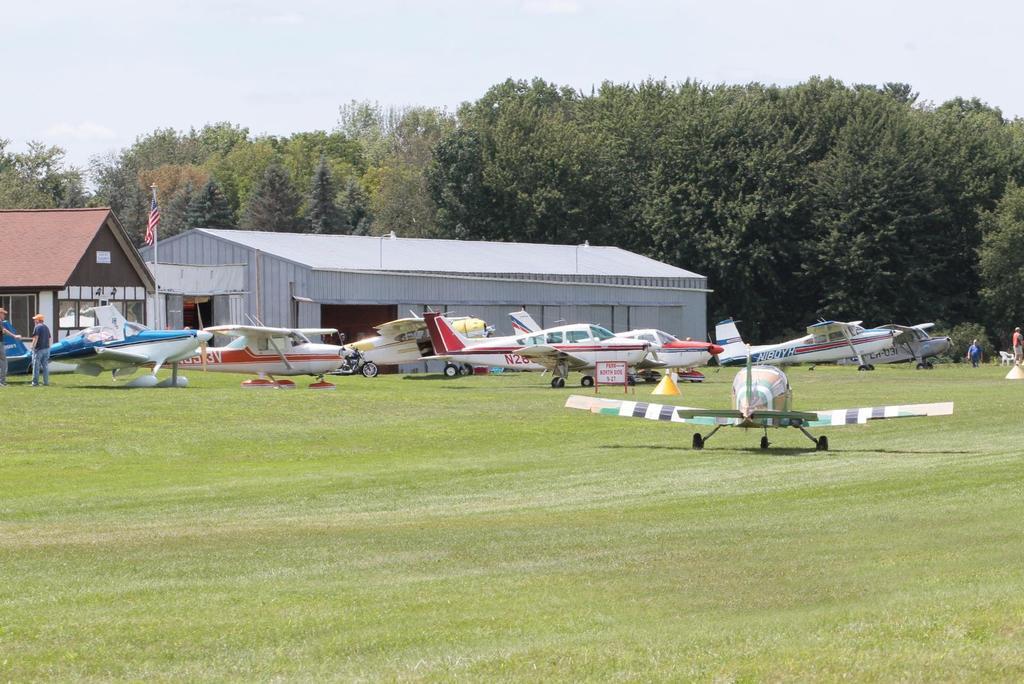Describe this image in one or two sentences. This image consists of jet planes parked on the ground. In the middle, there is a bike. At the bottom, there is green grass. In the front, there are two sheds. In the background, there are many trees. At the top, there is a sky. 